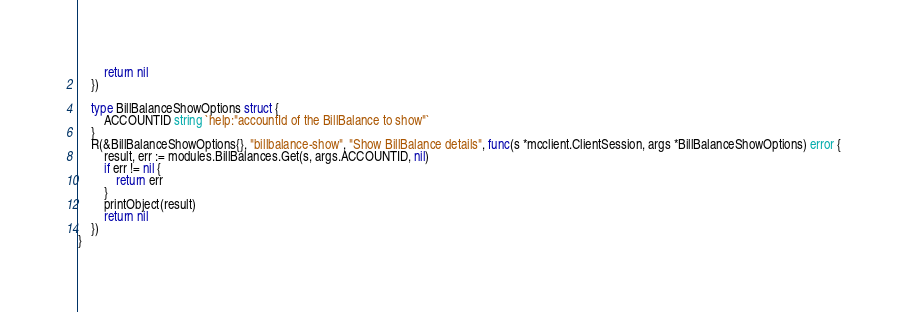<code> <loc_0><loc_0><loc_500><loc_500><_Go_>		return nil
	})

	type BillBalanceShowOptions struct {
		ACCOUNTID string `help:"accountId of the BillBalance to show"`
	}
	R(&BillBalanceShowOptions{}, "billbalance-show", "Show BillBalance details", func(s *mcclient.ClientSession, args *BillBalanceShowOptions) error {
		result, err := modules.BillBalances.Get(s, args.ACCOUNTID, nil)
		if err != nil {
			return err
		}
		printObject(result)
		return nil
	})
}
</code> 